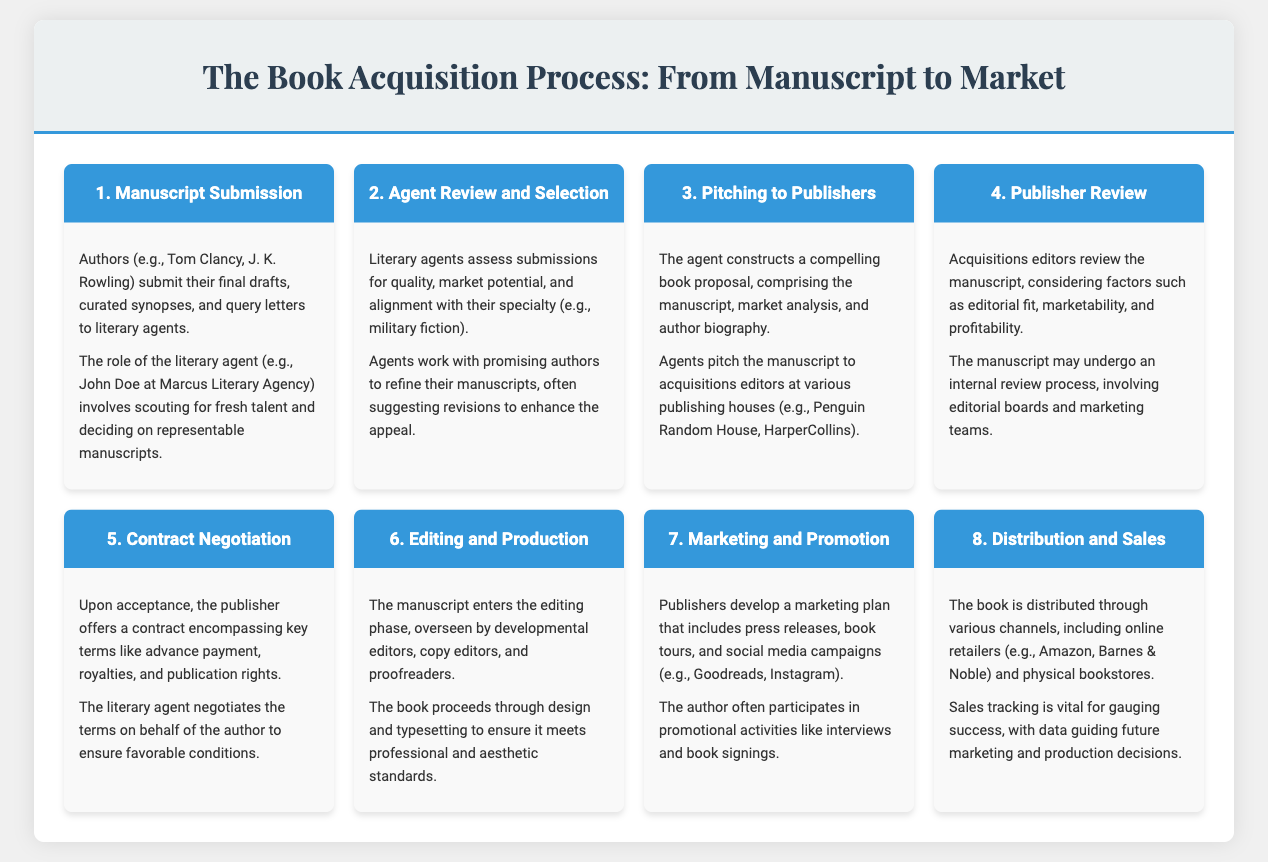What is the first step in the book acquisition process? The first step outlined in the infographic describes manuscript submission by authors.
Answer: Manuscript Submission Which genre do the literary agents specialize in according to the document? The document mentions that agents assess submissions specifically in the military fiction genre.
Answer: Military fiction What do agents construct to pitch to publishers? The infographic highlights the creation of a compelling book proposal, which includes several key components for pitching.
Answer: Book proposal Who reviews the manuscript after agents pitch to publishers? Acquisitions editors are responsible for reviewing the manuscript after it is pitched by agents.
Answer: Acquisitions editors What is a key aspect of the contract negotiation phase? The document states that the contract includes key terms like advance payment, royalties, and publication rights.
Answer: Advance payment What phase follows after the manuscript acceptance? The infographic indicates that after a manuscript is accepted, the next phase is editing and production.
Answer: Editing and Production How do publishers promote the book? The document specifies that publishers develop a marketing plan, which includes various promotional activities to raise awareness of the book.
Answer: Marketing plan Which phase involves developmental editors and proofreaders? The editing and production phase is described as involving developmental editors, copy editors, and proofreaders.
Answer: Editing and Production Where can the book be distributed? The infographic notes that the book is distributed through various channels, including online retailers and physical bookstores.
Answer: Online retailers and physical bookstores 